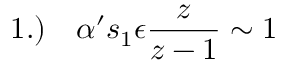<formula> <loc_0><loc_0><loc_500><loc_500>1 . ) \quad \alpha ^ { \prime } s _ { 1 } \epsilon \frac { z } z - 1 } \sim 1</formula> 